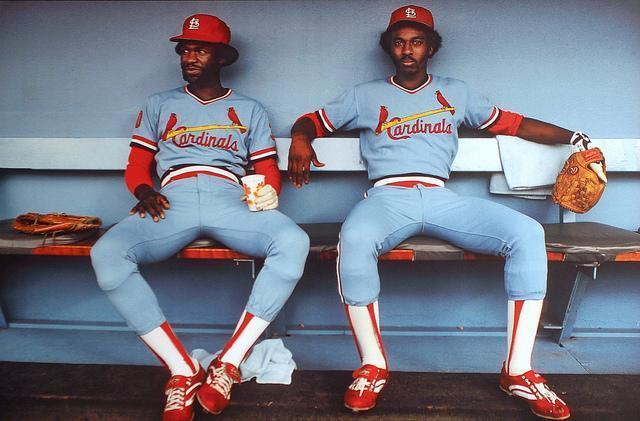How many people are in the picture?
Give a very brief answer. 2. 